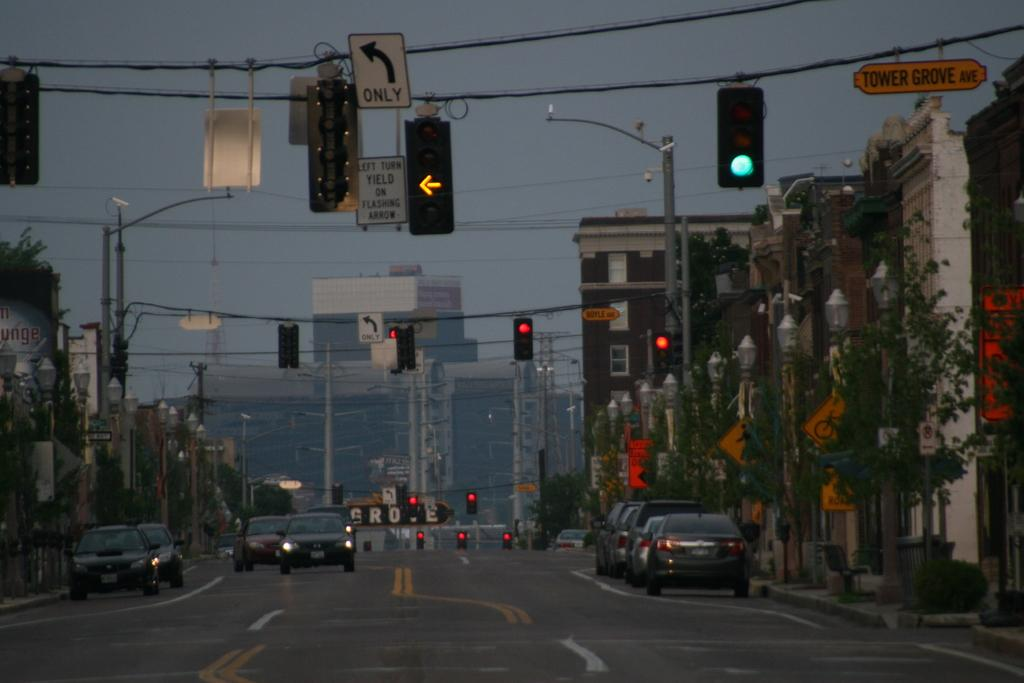<image>
Share a concise interpretation of the image provided. a yellow arrow and a left only sign is outdoors 